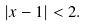<formula> <loc_0><loc_0><loc_500><loc_500>| x - 1 | < 2 .</formula> 